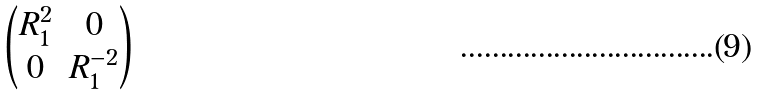<formula> <loc_0><loc_0><loc_500><loc_500>\begin{pmatrix} R _ { 1 } ^ { 2 } & 0 \\ 0 & R _ { 1 } ^ { - 2 } \end{pmatrix}</formula> 